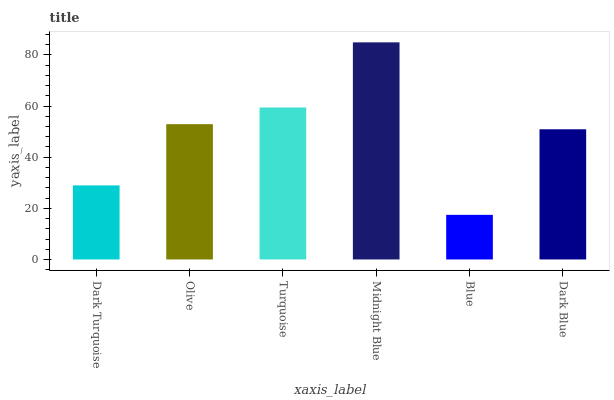Is Blue the minimum?
Answer yes or no. Yes. Is Midnight Blue the maximum?
Answer yes or no. Yes. Is Olive the minimum?
Answer yes or no. No. Is Olive the maximum?
Answer yes or no. No. Is Olive greater than Dark Turquoise?
Answer yes or no. Yes. Is Dark Turquoise less than Olive?
Answer yes or no. Yes. Is Dark Turquoise greater than Olive?
Answer yes or no. No. Is Olive less than Dark Turquoise?
Answer yes or no. No. Is Olive the high median?
Answer yes or no. Yes. Is Dark Blue the low median?
Answer yes or no. Yes. Is Dark Blue the high median?
Answer yes or no. No. Is Midnight Blue the low median?
Answer yes or no. No. 